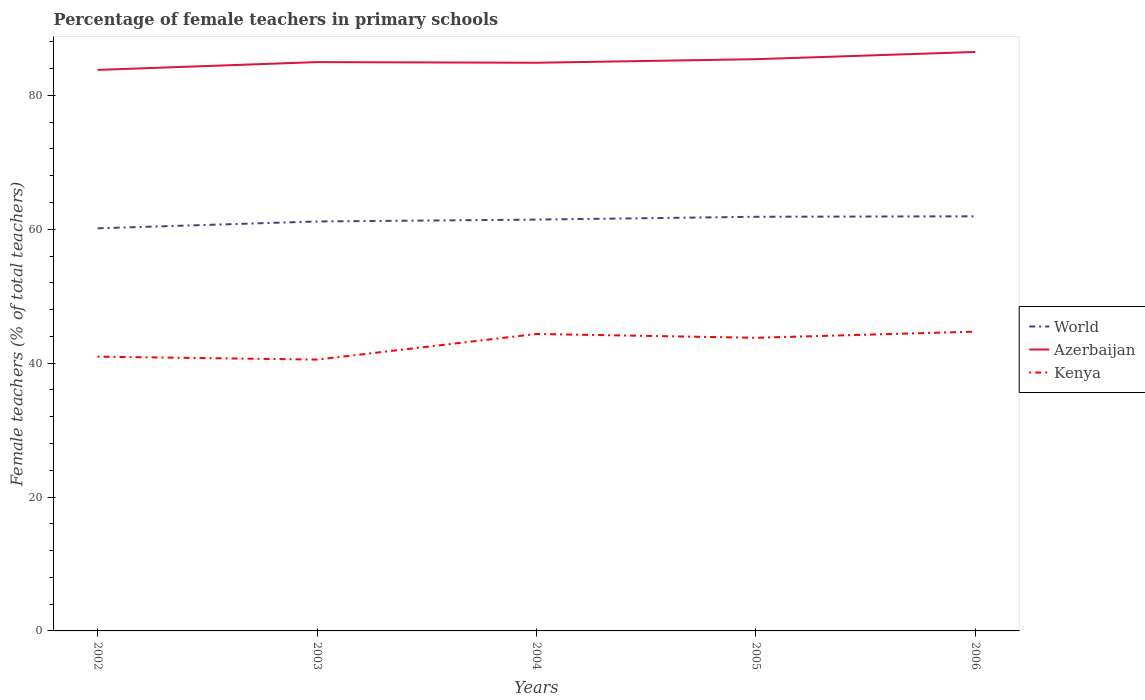How many different coloured lines are there?
Keep it short and to the point. 3. Is the number of lines equal to the number of legend labels?
Ensure brevity in your answer.  Yes. Across all years, what is the maximum percentage of female teachers in Azerbaijan?
Your answer should be compact. 83.81. What is the total percentage of female teachers in World in the graph?
Your response must be concise. -0.7. What is the difference between the highest and the second highest percentage of female teachers in World?
Provide a short and direct response. 1.8. What is the difference between the highest and the lowest percentage of female teachers in World?
Ensure brevity in your answer.  3. Is the percentage of female teachers in Azerbaijan strictly greater than the percentage of female teachers in Kenya over the years?
Your response must be concise. No. How many years are there in the graph?
Give a very brief answer. 5. What is the difference between two consecutive major ticks on the Y-axis?
Keep it short and to the point. 20. Does the graph contain grids?
Your answer should be compact. No. How many legend labels are there?
Keep it short and to the point. 3. What is the title of the graph?
Your response must be concise. Percentage of female teachers in primary schools. What is the label or title of the Y-axis?
Provide a short and direct response. Female teachers (% of total teachers). What is the Female teachers (% of total teachers) in World in 2002?
Your response must be concise. 60.14. What is the Female teachers (% of total teachers) of Azerbaijan in 2002?
Your answer should be compact. 83.81. What is the Female teachers (% of total teachers) in Kenya in 2002?
Make the answer very short. 40.97. What is the Female teachers (% of total teachers) of World in 2003?
Give a very brief answer. 61.17. What is the Female teachers (% of total teachers) of Azerbaijan in 2003?
Provide a succinct answer. 84.97. What is the Female teachers (% of total teachers) of Kenya in 2003?
Give a very brief answer. 40.53. What is the Female teachers (% of total teachers) of World in 2004?
Offer a very short reply. 61.45. What is the Female teachers (% of total teachers) of Azerbaijan in 2004?
Give a very brief answer. 84.88. What is the Female teachers (% of total teachers) in Kenya in 2004?
Keep it short and to the point. 44.36. What is the Female teachers (% of total teachers) of World in 2005?
Your response must be concise. 61.87. What is the Female teachers (% of total teachers) of Azerbaijan in 2005?
Make the answer very short. 85.41. What is the Female teachers (% of total teachers) of Kenya in 2005?
Offer a very short reply. 43.79. What is the Female teachers (% of total teachers) of World in 2006?
Your answer should be very brief. 61.94. What is the Female teachers (% of total teachers) of Azerbaijan in 2006?
Provide a succinct answer. 86.49. What is the Female teachers (% of total teachers) of Kenya in 2006?
Make the answer very short. 44.71. Across all years, what is the maximum Female teachers (% of total teachers) of World?
Ensure brevity in your answer.  61.94. Across all years, what is the maximum Female teachers (% of total teachers) of Azerbaijan?
Make the answer very short. 86.49. Across all years, what is the maximum Female teachers (% of total teachers) in Kenya?
Offer a terse response. 44.71. Across all years, what is the minimum Female teachers (% of total teachers) in World?
Ensure brevity in your answer.  60.14. Across all years, what is the minimum Female teachers (% of total teachers) of Azerbaijan?
Offer a very short reply. 83.81. Across all years, what is the minimum Female teachers (% of total teachers) in Kenya?
Offer a very short reply. 40.53. What is the total Female teachers (% of total teachers) in World in the graph?
Ensure brevity in your answer.  306.56. What is the total Female teachers (% of total teachers) of Azerbaijan in the graph?
Offer a very short reply. 425.56. What is the total Female teachers (% of total teachers) of Kenya in the graph?
Provide a short and direct response. 214.36. What is the difference between the Female teachers (% of total teachers) in World in 2002 and that in 2003?
Give a very brief answer. -1.02. What is the difference between the Female teachers (% of total teachers) in Azerbaijan in 2002 and that in 2003?
Keep it short and to the point. -1.17. What is the difference between the Female teachers (% of total teachers) in Kenya in 2002 and that in 2003?
Your answer should be very brief. 0.44. What is the difference between the Female teachers (% of total teachers) of World in 2002 and that in 2004?
Provide a short and direct response. -1.3. What is the difference between the Female teachers (% of total teachers) of Azerbaijan in 2002 and that in 2004?
Your response must be concise. -1.07. What is the difference between the Female teachers (% of total teachers) of Kenya in 2002 and that in 2004?
Provide a succinct answer. -3.39. What is the difference between the Female teachers (% of total teachers) in World in 2002 and that in 2005?
Ensure brevity in your answer.  -1.72. What is the difference between the Female teachers (% of total teachers) of Azerbaijan in 2002 and that in 2005?
Offer a terse response. -1.6. What is the difference between the Female teachers (% of total teachers) in Kenya in 2002 and that in 2005?
Your answer should be compact. -2.82. What is the difference between the Female teachers (% of total teachers) of World in 2002 and that in 2006?
Give a very brief answer. -1.79. What is the difference between the Female teachers (% of total teachers) in Azerbaijan in 2002 and that in 2006?
Provide a succinct answer. -2.68. What is the difference between the Female teachers (% of total teachers) of Kenya in 2002 and that in 2006?
Your answer should be compact. -3.74. What is the difference between the Female teachers (% of total teachers) in World in 2003 and that in 2004?
Provide a short and direct response. -0.28. What is the difference between the Female teachers (% of total teachers) of Azerbaijan in 2003 and that in 2004?
Your answer should be very brief. 0.1. What is the difference between the Female teachers (% of total teachers) in Kenya in 2003 and that in 2004?
Your answer should be compact. -3.83. What is the difference between the Female teachers (% of total teachers) of World in 2003 and that in 2005?
Keep it short and to the point. -0.7. What is the difference between the Female teachers (% of total teachers) in Azerbaijan in 2003 and that in 2005?
Keep it short and to the point. -0.44. What is the difference between the Female teachers (% of total teachers) of Kenya in 2003 and that in 2005?
Keep it short and to the point. -3.26. What is the difference between the Female teachers (% of total teachers) of World in 2003 and that in 2006?
Make the answer very short. -0.77. What is the difference between the Female teachers (% of total teachers) of Azerbaijan in 2003 and that in 2006?
Your answer should be compact. -1.52. What is the difference between the Female teachers (% of total teachers) of Kenya in 2003 and that in 2006?
Provide a succinct answer. -4.18. What is the difference between the Female teachers (% of total teachers) of World in 2004 and that in 2005?
Keep it short and to the point. -0.42. What is the difference between the Female teachers (% of total teachers) of Azerbaijan in 2004 and that in 2005?
Provide a short and direct response. -0.53. What is the difference between the Female teachers (% of total teachers) in Kenya in 2004 and that in 2005?
Provide a succinct answer. 0.57. What is the difference between the Female teachers (% of total teachers) of World in 2004 and that in 2006?
Offer a terse response. -0.49. What is the difference between the Female teachers (% of total teachers) of Azerbaijan in 2004 and that in 2006?
Your answer should be compact. -1.61. What is the difference between the Female teachers (% of total teachers) of Kenya in 2004 and that in 2006?
Provide a short and direct response. -0.35. What is the difference between the Female teachers (% of total teachers) of World in 2005 and that in 2006?
Give a very brief answer. -0.07. What is the difference between the Female teachers (% of total teachers) in Azerbaijan in 2005 and that in 2006?
Ensure brevity in your answer.  -1.08. What is the difference between the Female teachers (% of total teachers) of Kenya in 2005 and that in 2006?
Your response must be concise. -0.92. What is the difference between the Female teachers (% of total teachers) of World in 2002 and the Female teachers (% of total teachers) of Azerbaijan in 2003?
Provide a short and direct response. -24.83. What is the difference between the Female teachers (% of total teachers) of World in 2002 and the Female teachers (% of total teachers) of Kenya in 2003?
Your response must be concise. 19.61. What is the difference between the Female teachers (% of total teachers) in Azerbaijan in 2002 and the Female teachers (% of total teachers) in Kenya in 2003?
Offer a very short reply. 43.28. What is the difference between the Female teachers (% of total teachers) in World in 2002 and the Female teachers (% of total teachers) in Azerbaijan in 2004?
Offer a very short reply. -24.73. What is the difference between the Female teachers (% of total teachers) in World in 2002 and the Female teachers (% of total teachers) in Kenya in 2004?
Make the answer very short. 15.78. What is the difference between the Female teachers (% of total teachers) of Azerbaijan in 2002 and the Female teachers (% of total teachers) of Kenya in 2004?
Offer a very short reply. 39.45. What is the difference between the Female teachers (% of total teachers) in World in 2002 and the Female teachers (% of total teachers) in Azerbaijan in 2005?
Your answer should be very brief. -25.26. What is the difference between the Female teachers (% of total teachers) in World in 2002 and the Female teachers (% of total teachers) in Kenya in 2005?
Provide a short and direct response. 16.35. What is the difference between the Female teachers (% of total teachers) of Azerbaijan in 2002 and the Female teachers (% of total teachers) of Kenya in 2005?
Your answer should be very brief. 40.02. What is the difference between the Female teachers (% of total teachers) of World in 2002 and the Female teachers (% of total teachers) of Azerbaijan in 2006?
Your response must be concise. -26.35. What is the difference between the Female teachers (% of total teachers) in World in 2002 and the Female teachers (% of total teachers) in Kenya in 2006?
Give a very brief answer. 15.44. What is the difference between the Female teachers (% of total teachers) in Azerbaijan in 2002 and the Female teachers (% of total teachers) in Kenya in 2006?
Give a very brief answer. 39.1. What is the difference between the Female teachers (% of total teachers) of World in 2003 and the Female teachers (% of total teachers) of Azerbaijan in 2004?
Provide a short and direct response. -23.71. What is the difference between the Female teachers (% of total teachers) of World in 2003 and the Female teachers (% of total teachers) of Kenya in 2004?
Your answer should be compact. 16.81. What is the difference between the Female teachers (% of total teachers) in Azerbaijan in 2003 and the Female teachers (% of total teachers) in Kenya in 2004?
Provide a short and direct response. 40.61. What is the difference between the Female teachers (% of total teachers) in World in 2003 and the Female teachers (% of total teachers) in Azerbaijan in 2005?
Your answer should be very brief. -24.24. What is the difference between the Female teachers (% of total teachers) of World in 2003 and the Female teachers (% of total teachers) of Kenya in 2005?
Your answer should be compact. 17.38. What is the difference between the Female teachers (% of total teachers) in Azerbaijan in 2003 and the Female teachers (% of total teachers) in Kenya in 2005?
Your answer should be compact. 41.18. What is the difference between the Female teachers (% of total teachers) in World in 2003 and the Female teachers (% of total teachers) in Azerbaijan in 2006?
Provide a short and direct response. -25.32. What is the difference between the Female teachers (% of total teachers) of World in 2003 and the Female teachers (% of total teachers) of Kenya in 2006?
Your response must be concise. 16.46. What is the difference between the Female teachers (% of total teachers) of Azerbaijan in 2003 and the Female teachers (% of total teachers) of Kenya in 2006?
Provide a succinct answer. 40.26. What is the difference between the Female teachers (% of total teachers) in World in 2004 and the Female teachers (% of total teachers) in Azerbaijan in 2005?
Provide a short and direct response. -23.96. What is the difference between the Female teachers (% of total teachers) of World in 2004 and the Female teachers (% of total teachers) of Kenya in 2005?
Ensure brevity in your answer.  17.65. What is the difference between the Female teachers (% of total teachers) in Azerbaijan in 2004 and the Female teachers (% of total teachers) in Kenya in 2005?
Ensure brevity in your answer.  41.09. What is the difference between the Female teachers (% of total teachers) in World in 2004 and the Female teachers (% of total teachers) in Azerbaijan in 2006?
Your answer should be very brief. -25.04. What is the difference between the Female teachers (% of total teachers) in World in 2004 and the Female teachers (% of total teachers) in Kenya in 2006?
Make the answer very short. 16.74. What is the difference between the Female teachers (% of total teachers) in Azerbaijan in 2004 and the Female teachers (% of total teachers) in Kenya in 2006?
Your response must be concise. 40.17. What is the difference between the Female teachers (% of total teachers) of World in 2005 and the Female teachers (% of total teachers) of Azerbaijan in 2006?
Keep it short and to the point. -24.62. What is the difference between the Female teachers (% of total teachers) in World in 2005 and the Female teachers (% of total teachers) in Kenya in 2006?
Ensure brevity in your answer.  17.16. What is the difference between the Female teachers (% of total teachers) in Azerbaijan in 2005 and the Female teachers (% of total teachers) in Kenya in 2006?
Keep it short and to the point. 40.7. What is the average Female teachers (% of total teachers) of World per year?
Provide a succinct answer. 61.31. What is the average Female teachers (% of total teachers) in Azerbaijan per year?
Make the answer very short. 85.11. What is the average Female teachers (% of total teachers) in Kenya per year?
Give a very brief answer. 42.87. In the year 2002, what is the difference between the Female teachers (% of total teachers) in World and Female teachers (% of total teachers) in Azerbaijan?
Provide a short and direct response. -23.66. In the year 2002, what is the difference between the Female teachers (% of total teachers) in World and Female teachers (% of total teachers) in Kenya?
Offer a terse response. 19.17. In the year 2002, what is the difference between the Female teachers (% of total teachers) of Azerbaijan and Female teachers (% of total teachers) of Kenya?
Offer a terse response. 42.84. In the year 2003, what is the difference between the Female teachers (% of total teachers) in World and Female teachers (% of total teachers) in Azerbaijan?
Offer a very short reply. -23.81. In the year 2003, what is the difference between the Female teachers (% of total teachers) in World and Female teachers (% of total teachers) in Kenya?
Provide a short and direct response. 20.63. In the year 2003, what is the difference between the Female teachers (% of total teachers) of Azerbaijan and Female teachers (% of total teachers) of Kenya?
Make the answer very short. 44.44. In the year 2004, what is the difference between the Female teachers (% of total teachers) in World and Female teachers (% of total teachers) in Azerbaijan?
Give a very brief answer. -23.43. In the year 2004, what is the difference between the Female teachers (% of total teachers) of World and Female teachers (% of total teachers) of Kenya?
Offer a terse response. 17.09. In the year 2004, what is the difference between the Female teachers (% of total teachers) of Azerbaijan and Female teachers (% of total teachers) of Kenya?
Provide a short and direct response. 40.52. In the year 2005, what is the difference between the Female teachers (% of total teachers) of World and Female teachers (% of total teachers) of Azerbaijan?
Offer a very short reply. -23.54. In the year 2005, what is the difference between the Female teachers (% of total teachers) of World and Female teachers (% of total teachers) of Kenya?
Provide a short and direct response. 18.08. In the year 2005, what is the difference between the Female teachers (% of total teachers) in Azerbaijan and Female teachers (% of total teachers) in Kenya?
Provide a succinct answer. 41.62. In the year 2006, what is the difference between the Female teachers (% of total teachers) of World and Female teachers (% of total teachers) of Azerbaijan?
Give a very brief answer. -24.55. In the year 2006, what is the difference between the Female teachers (% of total teachers) in World and Female teachers (% of total teachers) in Kenya?
Your answer should be compact. 17.23. In the year 2006, what is the difference between the Female teachers (% of total teachers) in Azerbaijan and Female teachers (% of total teachers) in Kenya?
Ensure brevity in your answer.  41.78. What is the ratio of the Female teachers (% of total teachers) of World in 2002 to that in 2003?
Give a very brief answer. 0.98. What is the ratio of the Female teachers (% of total teachers) of Azerbaijan in 2002 to that in 2003?
Give a very brief answer. 0.99. What is the ratio of the Female teachers (% of total teachers) in Kenya in 2002 to that in 2003?
Ensure brevity in your answer.  1.01. What is the ratio of the Female teachers (% of total teachers) in World in 2002 to that in 2004?
Make the answer very short. 0.98. What is the ratio of the Female teachers (% of total teachers) of Azerbaijan in 2002 to that in 2004?
Provide a short and direct response. 0.99. What is the ratio of the Female teachers (% of total teachers) of Kenya in 2002 to that in 2004?
Your answer should be compact. 0.92. What is the ratio of the Female teachers (% of total teachers) of World in 2002 to that in 2005?
Offer a very short reply. 0.97. What is the ratio of the Female teachers (% of total teachers) in Azerbaijan in 2002 to that in 2005?
Give a very brief answer. 0.98. What is the ratio of the Female teachers (% of total teachers) of Kenya in 2002 to that in 2005?
Your answer should be compact. 0.94. What is the ratio of the Female teachers (% of total teachers) of Azerbaijan in 2002 to that in 2006?
Your response must be concise. 0.97. What is the ratio of the Female teachers (% of total teachers) in Kenya in 2002 to that in 2006?
Keep it short and to the point. 0.92. What is the ratio of the Female teachers (% of total teachers) in Azerbaijan in 2003 to that in 2004?
Ensure brevity in your answer.  1. What is the ratio of the Female teachers (% of total teachers) in Kenya in 2003 to that in 2004?
Make the answer very short. 0.91. What is the ratio of the Female teachers (% of total teachers) in World in 2003 to that in 2005?
Provide a short and direct response. 0.99. What is the ratio of the Female teachers (% of total teachers) in Kenya in 2003 to that in 2005?
Offer a terse response. 0.93. What is the ratio of the Female teachers (% of total teachers) of World in 2003 to that in 2006?
Your answer should be very brief. 0.99. What is the ratio of the Female teachers (% of total teachers) in Azerbaijan in 2003 to that in 2006?
Offer a terse response. 0.98. What is the ratio of the Female teachers (% of total teachers) in Kenya in 2003 to that in 2006?
Give a very brief answer. 0.91. What is the ratio of the Female teachers (% of total teachers) of Azerbaijan in 2004 to that in 2005?
Offer a terse response. 0.99. What is the ratio of the Female teachers (% of total teachers) in Kenya in 2004 to that in 2005?
Your answer should be very brief. 1.01. What is the ratio of the Female teachers (% of total teachers) in World in 2004 to that in 2006?
Your response must be concise. 0.99. What is the ratio of the Female teachers (% of total teachers) of Azerbaijan in 2004 to that in 2006?
Make the answer very short. 0.98. What is the ratio of the Female teachers (% of total teachers) of Kenya in 2004 to that in 2006?
Your answer should be very brief. 0.99. What is the ratio of the Female teachers (% of total teachers) in Azerbaijan in 2005 to that in 2006?
Offer a terse response. 0.99. What is the ratio of the Female teachers (% of total teachers) of Kenya in 2005 to that in 2006?
Provide a short and direct response. 0.98. What is the difference between the highest and the second highest Female teachers (% of total teachers) in World?
Make the answer very short. 0.07. What is the difference between the highest and the second highest Female teachers (% of total teachers) of Azerbaijan?
Give a very brief answer. 1.08. What is the difference between the highest and the second highest Female teachers (% of total teachers) of Kenya?
Keep it short and to the point. 0.35. What is the difference between the highest and the lowest Female teachers (% of total teachers) of World?
Your answer should be very brief. 1.79. What is the difference between the highest and the lowest Female teachers (% of total teachers) of Azerbaijan?
Give a very brief answer. 2.68. What is the difference between the highest and the lowest Female teachers (% of total teachers) in Kenya?
Make the answer very short. 4.18. 